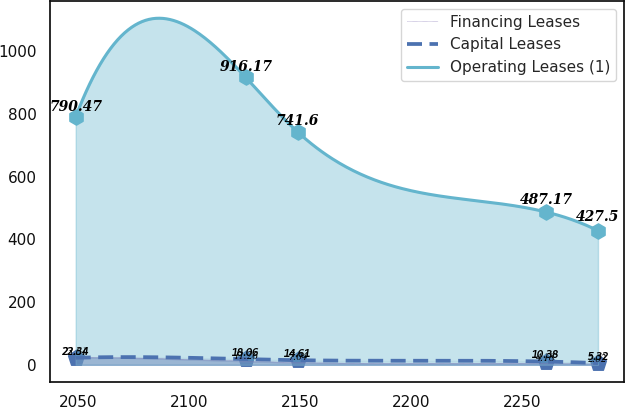Convert chart. <chart><loc_0><loc_0><loc_500><loc_500><line_chart><ecel><fcel>Financing Leases<fcel>Capital Leases<fcel>Operating Leases (1)<nl><fcel>2048.81<fcel>23.61<fcel>22.34<fcel>790.47<nl><fcel>2125.51<fcel>11.26<fcel>18.06<fcel>916.17<nl><fcel>2149.03<fcel>7.04<fcel>14.61<fcel>741.6<nl><fcel>2260.93<fcel>4.18<fcel>10.38<fcel>487.17<nl><fcel>2284.45<fcel>2.02<fcel>5.32<fcel>427.5<nl></chart> 